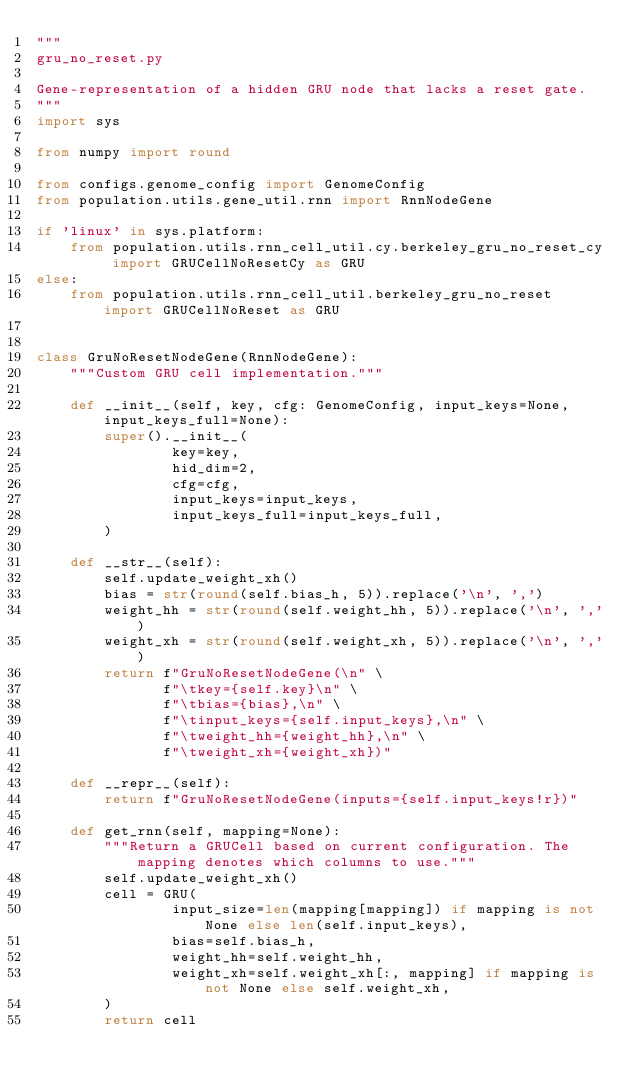<code> <loc_0><loc_0><loc_500><loc_500><_Python_>"""
gru_no_reset.py

Gene-representation of a hidden GRU node that lacks a reset gate.
"""
import sys

from numpy import round

from configs.genome_config import GenomeConfig
from population.utils.gene_util.rnn import RnnNodeGene

if 'linux' in sys.platform:
    from population.utils.rnn_cell_util.cy.berkeley_gru_no_reset_cy import GRUCellNoResetCy as GRU
else:
    from population.utils.rnn_cell_util.berkeley_gru_no_reset import GRUCellNoReset as GRU


class GruNoResetNodeGene(RnnNodeGene):
    """Custom GRU cell implementation."""
    
    def __init__(self, key, cfg: GenomeConfig, input_keys=None, input_keys_full=None):
        super().__init__(
                key=key,
                hid_dim=2,
                cfg=cfg,
                input_keys=input_keys,
                input_keys_full=input_keys_full,
        )
    
    def __str__(self):
        self.update_weight_xh()
        bias = str(round(self.bias_h, 5)).replace('\n', ',')
        weight_hh = str(round(self.weight_hh, 5)).replace('\n', ',')
        weight_xh = str(round(self.weight_xh, 5)).replace('\n', ',')
        return f"GruNoResetNodeGene(\n" \
               f"\tkey={self.key}\n" \
               f"\tbias={bias},\n" \
               f"\tinput_keys={self.input_keys},\n" \
               f"\tweight_hh={weight_hh},\n" \
               f"\tweight_xh={weight_xh})"
    
    def __repr__(self):
        return f"GruNoResetNodeGene(inputs={self.input_keys!r})"
    
    def get_rnn(self, mapping=None):
        """Return a GRUCell based on current configuration. The mapping denotes which columns to use."""
        self.update_weight_xh()
        cell = GRU(
                input_size=len(mapping[mapping]) if mapping is not None else len(self.input_keys),
                bias=self.bias_h,
                weight_hh=self.weight_hh,
                weight_xh=self.weight_xh[:, mapping] if mapping is not None else self.weight_xh,
        )
        return cell
</code> 